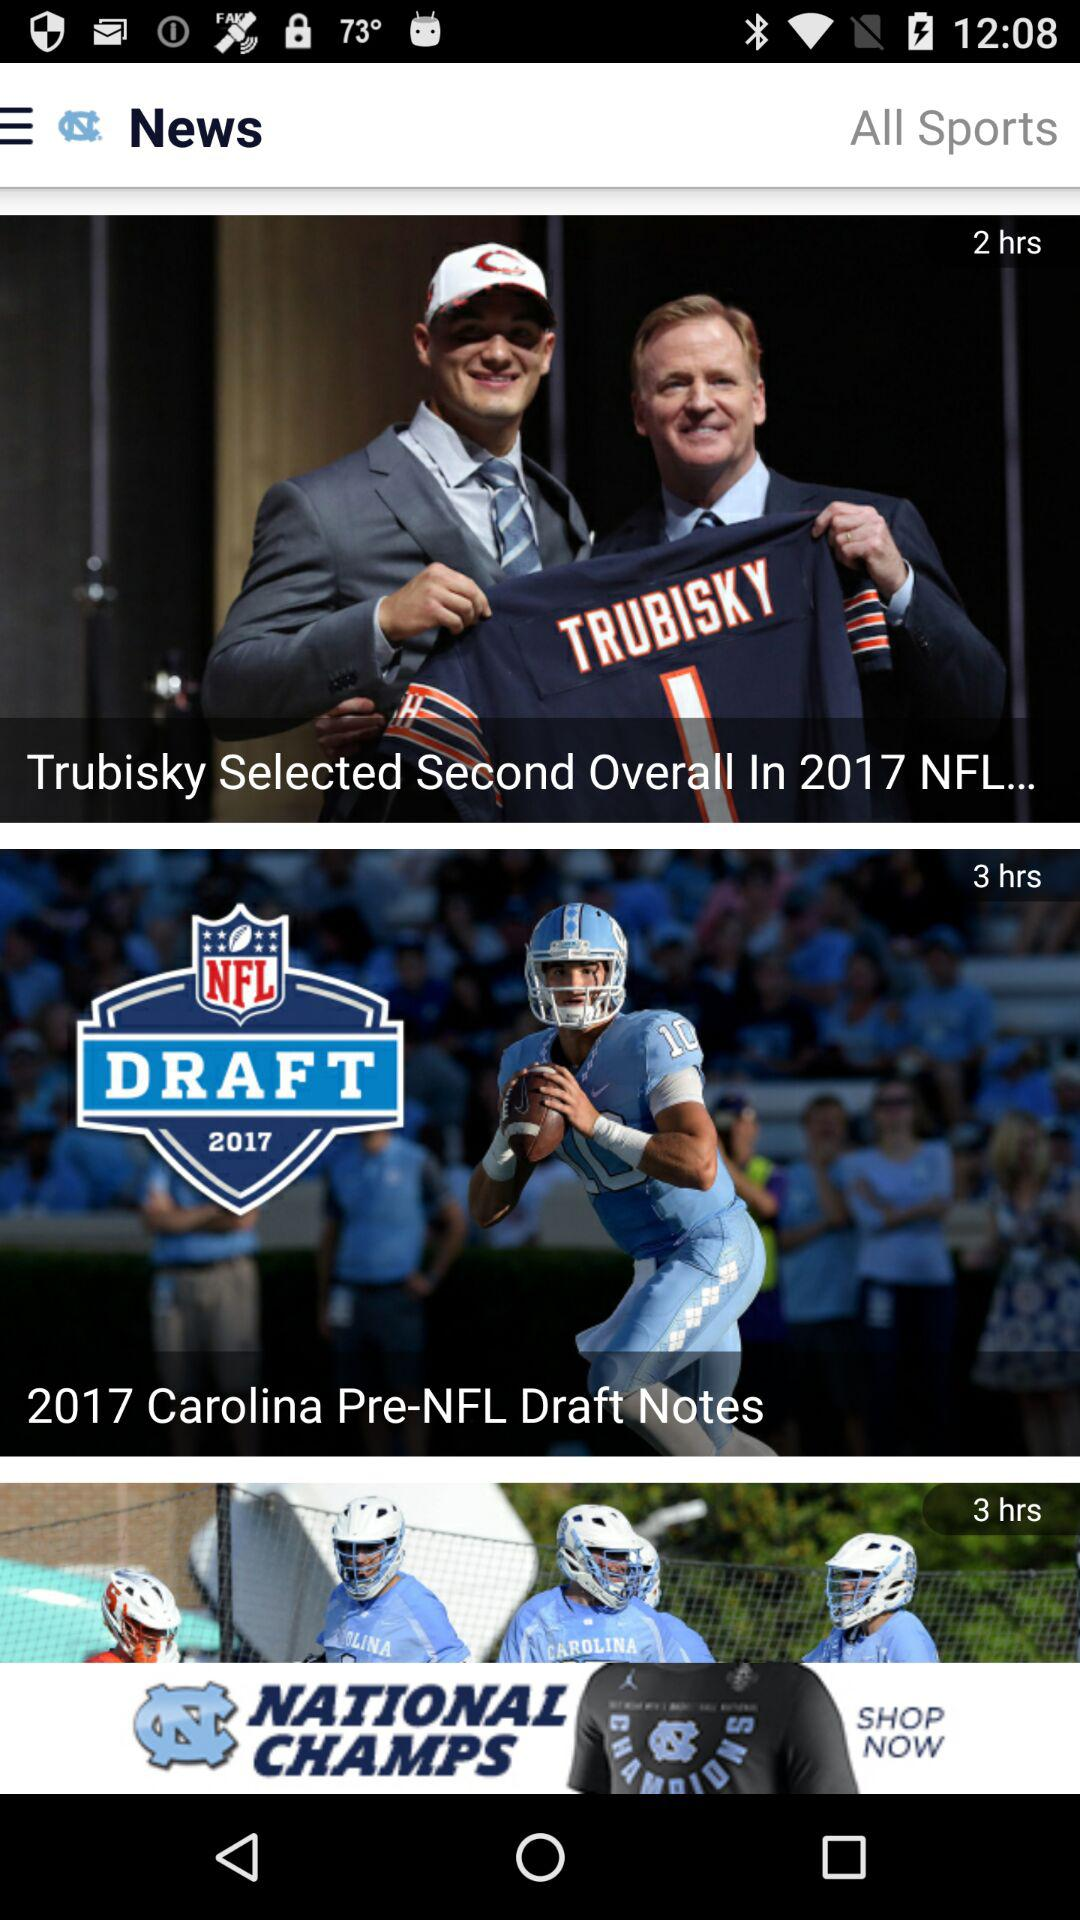What is the year? The year is 2017. 